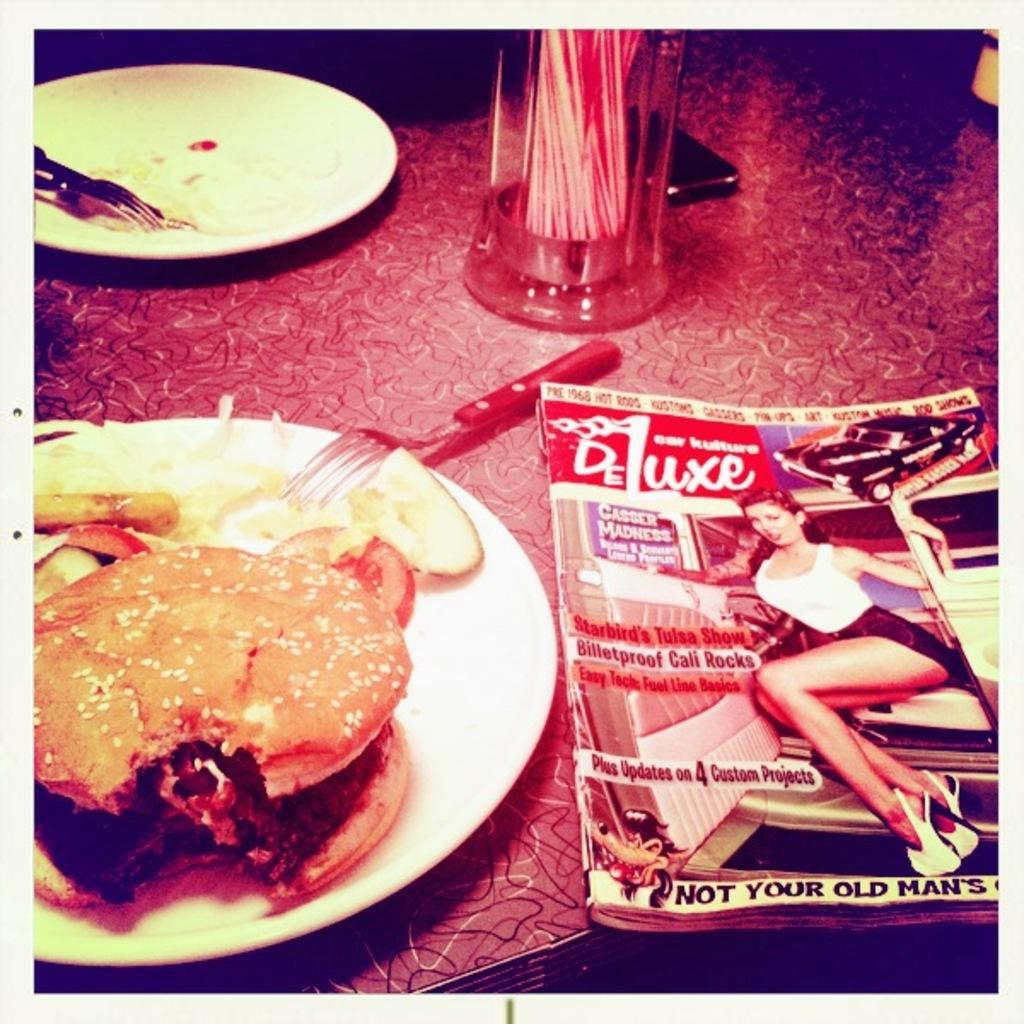What is the main piece of furniture in the image? There is a table in the image. What is placed on the table? There are plates on the table, and they contain burgers and other food items. What utensils are present on the table? There are spoons on the table. What type of beverage container is on the table? There is a glass on the table. What else can be seen on the table besides food and utensils? There is a mobile and a magazine on the table. What type of leaf is used as a napkin in the image? There is no leaf used as a napkin in the image; napkins are not mentioned in the provided facts. 